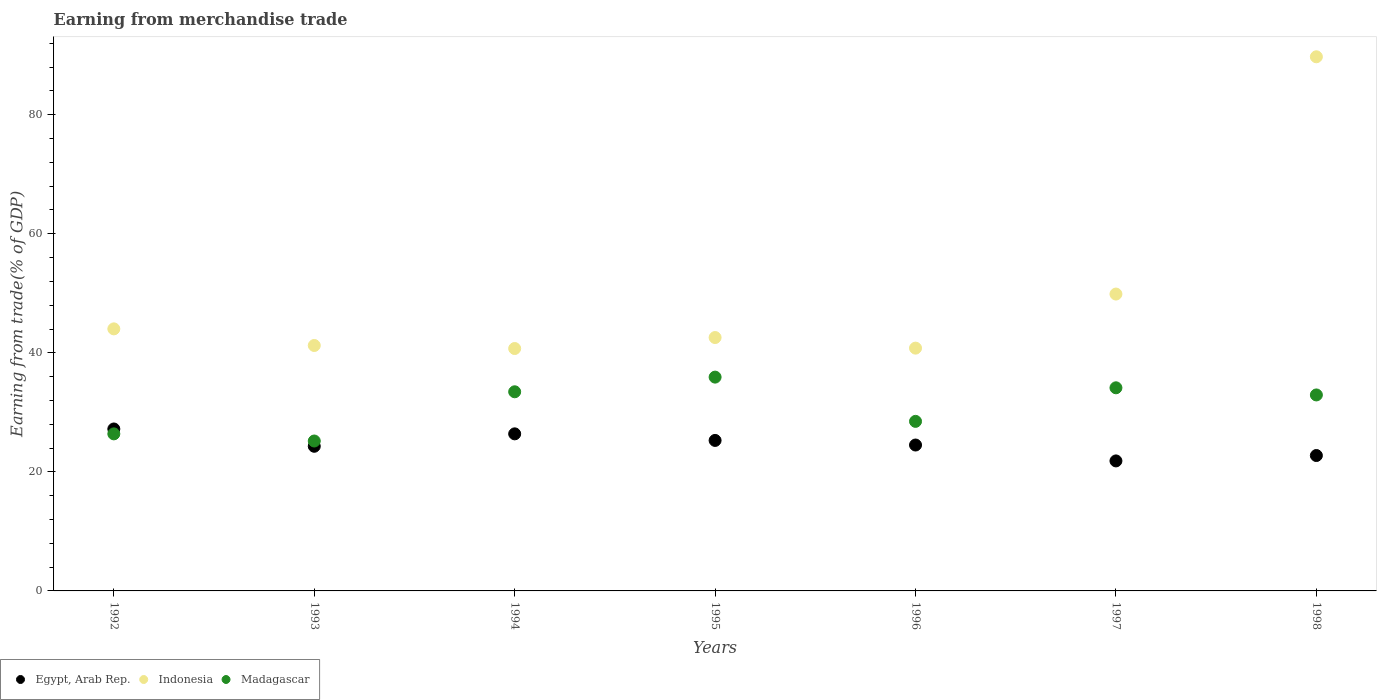What is the earnings from trade in Indonesia in 1993?
Your answer should be very brief. 41.23. Across all years, what is the maximum earnings from trade in Madagascar?
Provide a short and direct response. 35.92. Across all years, what is the minimum earnings from trade in Indonesia?
Make the answer very short. 40.72. In which year was the earnings from trade in Indonesia maximum?
Make the answer very short. 1998. What is the total earnings from trade in Madagascar in the graph?
Your answer should be very brief. 216.48. What is the difference between the earnings from trade in Madagascar in 1992 and that in 1993?
Your response must be concise. 1.2. What is the difference between the earnings from trade in Egypt, Arab Rep. in 1997 and the earnings from trade in Madagascar in 1996?
Provide a succinct answer. -6.64. What is the average earnings from trade in Egypt, Arab Rep. per year?
Your answer should be very brief. 24.61. In the year 1993, what is the difference between the earnings from trade in Indonesia and earnings from trade in Madagascar?
Your response must be concise. 16.05. In how many years, is the earnings from trade in Indonesia greater than 84 %?
Your answer should be very brief. 1. What is the ratio of the earnings from trade in Indonesia in 1993 to that in 1997?
Provide a succinct answer. 0.83. Is the earnings from trade in Madagascar in 1993 less than that in 1997?
Ensure brevity in your answer.  Yes. What is the difference between the highest and the second highest earnings from trade in Egypt, Arab Rep.?
Provide a succinct answer. 0.82. What is the difference between the highest and the lowest earnings from trade in Madagascar?
Provide a succinct answer. 10.73. Does the earnings from trade in Egypt, Arab Rep. monotonically increase over the years?
Give a very brief answer. No. Is the earnings from trade in Indonesia strictly greater than the earnings from trade in Madagascar over the years?
Provide a succinct answer. Yes. How many dotlines are there?
Provide a succinct answer. 3. Does the graph contain any zero values?
Offer a very short reply. No. What is the title of the graph?
Give a very brief answer. Earning from merchandise trade. Does "Bhutan" appear as one of the legend labels in the graph?
Provide a succinct answer. No. What is the label or title of the X-axis?
Keep it short and to the point. Years. What is the label or title of the Y-axis?
Offer a terse response. Earning from trade(% of GDP). What is the Earning from trade(% of GDP) in Egypt, Arab Rep. in 1992?
Provide a succinct answer. 27.21. What is the Earning from trade(% of GDP) of Indonesia in 1992?
Your answer should be compact. 44.03. What is the Earning from trade(% of GDP) of Madagascar in 1992?
Keep it short and to the point. 26.38. What is the Earning from trade(% of GDP) in Egypt, Arab Rep. in 1993?
Offer a terse response. 24.3. What is the Earning from trade(% of GDP) of Indonesia in 1993?
Provide a short and direct response. 41.23. What is the Earning from trade(% of GDP) in Madagascar in 1993?
Give a very brief answer. 25.19. What is the Earning from trade(% of GDP) of Egypt, Arab Rep. in 1994?
Provide a succinct answer. 26.39. What is the Earning from trade(% of GDP) of Indonesia in 1994?
Your answer should be compact. 40.72. What is the Earning from trade(% of GDP) in Madagascar in 1994?
Offer a very short reply. 33.46. What is the Earning from trade(% of GDP) in Egypt, Arab Rep. in 1995?
Offer a very short reply. 25.28. What is the Earning from trade(% of GDP) in Indonesia in 1995?
Offer a terse response. 42.57. What is the Earning from trade(% of GDP) of Madagascar in 1995?
Your answer should be very brief. 35.92. What is the Earning from trade(% of GDP) in Egypt, Arab Rep. in 1996?
Your answer should be very brief. 24.51. What is the Earning from trade(% of GDP) in Indonesia in 1996?
Keep it short and to the point. 40.79. What is the Earning from trade(% of GDP) in Madagascar in 1996?
Your answer should be very brief. 28.49. What is the Earning from trade(% of GDP) in Egypt, Arab Rep. in 1997?
Your answer should be very brief. 21.84. What is the Earning from trade(% of GDP) of Indonesia in 1997?
Make the answer very short. 49.87. What is the Earning from trade(% of GDP) of Madagascar in 1997?
Your answer should be very brief. 34.13. What is the Earning from trade(% of GDP) in Egypt, Arab Rep. in 1998?
Offer a terse response. 22.75. What is the Earning from trade(% of GDP) of Indonesia in 1998?
Make the answer very short. 89.74. What is the Earning from trade(% of GDP) in Madagascar in 1998?
Provide a succinct answer. 32.93. Across all years, what is the maximum Earning from trade(% of GDP) in Egypt, Arab Rep.?
Provide a short and direct response. 27.21. Across all years, what is the maximum Earning from trade(% of GDP) in Indonesia?
Your response must be concise. 89.74. Across all years, what is the maximum Earning from trade(% of GDP) of Madagascar?
Give a very brief answer. 35.92. Across all years, what is the minimum Earning from trade(% of GDP) in Egypt, Arab Rep.?
Give a very brief answer. 21.84. Across all years, what is the minimum Earning from trade(% of GDP) in Indonesia?
Give a very brief answer. 40.72. Across all years, what is the minimum Earning from trade(% of GDP) of Madagascar?
Give a very brief answer. 25.19. What is the total Earning from trade(% of GDP) in Egypt, Arab Rep. in the graph?
Keep it short and to the point. 172.28. What is the total Earning from trade(% of GDP) in Indonesia in the graph?
Provide a short and direct response. 348.95. What is the total Earning from trade(% of GDP) in Madagascar in the graph?
Make the answer very short. 216.48. What is the difference between the Earning from trade(% of GDP) in Egypt, Arab Rep. in 1992 and that in 1993?
Keep it short and to the point. 2.91. What is the difference between the Earning from trade(% of GDP) of Indonesia in 1992 and that in 1993?
Offer a very short reply. 2.79. What is the difference between the Earning from trade(% of GDP) in Madagascar in 1992 and that in 1993?
Provide a succinct answer. 1.2. What is the difference between the Earning from trade(% of GDP) in Egypt, Arab Rep. in 1992 and that in 1994?
Your response must be concise. 0.82. What is the difference between the Earning from trade(% of GDP) in Indonesia in 1992 and that in 1994?
Your answer should be very brief. 3.3. What is the difference between the Earning from trade(% of GDP) in Madagascar in 1992 and that in 1994?
Your response must be concise. -7.07. What is the difference between the Earning from trade(% of GDP) of Egypt, Arab Rep. in 1992 and that in 1995?
Your response must be concise. 1.92. What is the difference between the Earning from trade(% of GDP) in Indonesia in 1992 and that in 1995?
Provide a succinct answer. 1.46. What is the difference between the Earning from trade(% of GDP) in Madagascar in 1992 and that in 1995?
Offer a terse response. -9.53. What is the difference between the Earning from trade(% of GDP) in Egypt, Arab Rep. in 1992 and that in 1996?
Make the answer very short. 2.7. What is the difference between the Earning from trade(% of GDP) of Indonesia in 1992 and that in 1996?
Give a very brief answer. 3.24. What is the difference between the Earning from trade(% of GDP) of Madagascar in 1992 and that in 1996?
Your answer should be compact. -2.1. What is the difference between the Earning from trade(% of GDP) in Egypt, Arab Rep. in 1992 and that in 1997?
Give a very brief answer. 5.37. What is the difference between the Earning from trade(% of GDP) of Indonesia in 1992 and that in 1997?
Provide a short and direct response. -5.85. What is the difference between the Earning from trade(% of GDP) in Madagascar in 1992 and that in 1997?
Ensure brevity in your answer.  -7.74. What is the difference between the Earning from trade(% of GDP) in Egypt, Arab Rep. in 1992 and that in 1998?
Provide a short and direct response. 4.46. What is the difference between the Earning from trade(% of GDP) in Indonesia in 1992 and that in 1998?
Offer a very short reply. -45.71. What is the difference between the Earning from trade(% of GDP) in Madagascar in 1992 and that in 1998?
Ensure brevity in your answer.  -6.54. What is the difference between the Earning from trade(% of GDP) in Egypt, Arab Rep. in 1993 and that in 1994?
Your answer should be compact. -2.09. What is the difference between the Earning from trade(% of GDP) of Indonesia in 1993 and that in 1994?
Your answer should be compact. 0.51. What is the difference between the Earning from trade(% of GDP) in Madagascar in 1993 and that in 1994?
Offer a very short reply. -8.27. What is the difference between the Earning from trade(% of GDP) of Egypt, Arab Rep. in 1993 and that in 1995?
Provide a short and direct response. -0.98. What is the difference between the Earning from trade(% of GDP) of Indonesia in 1993 and that in 1995?
Your answer should be compact. -1.34. What is the difference between the Earning from trade(% of GDP) in Madagascar in 1993 and that in 1995?
Your response must be concise. -10.73. What is the difference between the Earning from trade(% of GDP) in Egypt, Arab Rep. in 1993 and that in 1996?
Offer a very short reply. -0.21. What is the difference between the Earning from trade(% of GDP) of Indonesia in 1993 and that in 1996?
Ensure brevity in your answer.  0.44. What is the difference between the Earning from trade(% of GDP) of Madagascar in 1993 and that in 1996?
Give a very brief answer. -3.3. What is the difference between the Earning from trade(% of GDP) of Egypt, Arab Rep. in 1993 and that in 1997?
Make the answer very short. 2.46. What is the difference between the Earning from trade(% of GDP) in Indonesia in 1993 and that in 1997?
Make the answer very short. -8.64. What is the difference between the Earning from trade(% of GDP) in Madagascar in 1993 and that in 1997?
Your answer should be very brief. -8.94. What is the difference between the Earning from trade(% of GDP) of Egypt, Arab Rep. in 1993 and that in 1998?
Your answer should be compact. 1.55. What is the difference between the Earning from trade(% of GDP) in Indonesia in 1993 and that in 1998?
Provide a succinct answer. -48.5. What is the difference between the Earning from trade(% of GDP) of Madagascar in 1993 and that in 1998?
Offer a very short reply. -7.74. What is the difference between the Earning from trade(% of GDP) in Egypt, Arab Rep. in 1994 and that in 1995?
Make the answer very short. 1.11. What is the difference between the Earning from trade(% of GDP) in Indonesia in 1994 and that in 1995?
Provide a short and direct response. -1.85. What is the difference between the Earning from trade(% of GDP) in Madagascar in 1994 and that in 1995?
Give a very brief answer. -2.46. What is the difference between the Earning from trade(% of GDP) in Egypt, Arab Rep. in 1994 and that in 1996?
Provide a short and direct response. 1.88. What is the difference between the Earning from trade(% of GDP) of Indonesia in 1994 and that in 1996?
Give a very brief answer. -0.07. What is the difference between the Earning from trade(% of GDP) in Madagascar in 1994 and that in 1996?
Your response must be concise. 4.97. What is the difference between the Earning from trade(% of GDP) of Egypt, Arab Rep. in 1994 and that in 1997?
Provide a succinct answer. 4.55. What is the difference between the Earning from trade(% of GDP) in Indonesia in 1994 and that in 1997?
Your answer should be very brief. -9.15. What is the difference between the Earning from trade(% of GDP) of Madagascar in 1994 and that in 1997?
Offer a terse response. -0.67. What is the difference between the Earning from trade(% of GDP) of Egypt, Arab Rep. in 1994 and that in 1998?
Keep it short and to the point. 3.64. What is the difference between the Earning from trade(% of GDP) in Indonesia in 1994 and that in 1998?
Offer a terse response. -49.01. What is the difference between the Earning from trade(% of GDP) of Madagascar in 1994 and that in 1998?
Provide a short and direct response. 0.53. What is the difference between the Earning from trade(% of GDP) in Egypt, Arab Rep. in 1995 and that in 1996?
Provide a short and direct response. 0.77. What is the difference between the Earning from trade(% of GDP) in Indonesia in 1995 and that in 1996?
Give a very brief answer. 1.78. What is the difference between the Earning from trade(% of GDP) of Madagascar in 1995 and that in 1996?
Your answer should be compact. 7.43. What is the difference between the Earning from trade(% of GDP) of Egypt, Arab Rep. in 1995 and that in 1997?
Keep it short and to the point. 3.44. What is the difference between the Earning from trade(% of GDP) of Indonesia in 1995 and that in 1997?
Your response must be concise. -7.3. What is the difference between the Earning from trade(% of GDP) of Madagascar in 1995 and that in 1997?
Your response must be concise. 1.79. What is the difference between the Earning from trade(% of GDP) in Egypt, Arab Rep. in 1995 and that in 1998?
Your answer should be very brief. 2.54. What is the difference between the Earning from trade(% of GDP) of Indonesia in 1995 and that in 1998?
Your answer should be very brief. -47.17. What is the difference between the Earning from trade(% of GDP) of Madagascar in 1995 and that in 1998?
Your response must be concise. 2.99. What is the difference between the Earning from trade(% of GDP) of Egypt, Arab Rep. in 1996 and that in 1997?
Keep it short and to the point. 2.67. What is the difference between the Earning from trade(% of GDP) of Indonesia in 1996 and that in 1997?
Your answer should be very brief. -9.08. What is the difference between the Earning from trade(% of GDP) of Madagascar in 1996 and that in 1997?
Give a very brief answer. -5.64. What is the difference between the Earning from trade(% of GDP) of Egypt, Arab Rep. in 1996 and that in 1998?
Your response must be concise. 1.76. What is the difference between the Earning from trade(% of GDP) of Indonesia in 1996 and that in 1998?
Offer a very short reply. -48.95. What is the difference between the Earning from trade(% of GDP) of Madagascar in 1996 and that in 1998?
Your answer should be very brief. -4.44. What is the difference between the Earning from trade(% of GDP) in Egypt, Arab Rep. in 1997 and that in 1998?
Offer a terse response. -0.91. What is the difference between the Earning from trade(% of GDP) of Indonesia in 1997 and that in 1998?
Offer a terse response. -39.86. What is the difference between the Earning from trade(% of GDP) of Madagascar in 1997 and that in 1998?
Keep it short and to the point. 1.2. What is the difference between the Earning from trade(% of GDP) in Egypt, Arab Rep. in 1992 and the Earning from trade(% of GDP) in Indonesia in 1993?
Your answer should be very brief. -14.03. What is the difference between the Earning from trade(% of GDP) in Egypt, Arab Rep. in 1992 and the Earning from trade(% of GDP) in Madagascar in 1993?
Your response must be concise. 2.02. What is the difference between the Earning from trade(% of GDP) of Indonesia in 1992 and the Earning from trade(% of GDP) of Madagascar in 1993?
Make the answer very short. 18.84. What is the difference between the Earning from trade(% of GDP) in Egypt, Arab Rep. in 1992 and the Earning from trade(% of GDP) in Indonesia in 1994?
Keep it short and to the point. -13.52. What is the difference between the Earning from trade(% of GDP) of Egypt, Arab Rep. in 1992 and the Earning from trade(% of GDP) of Madagascar in 1994?
Make the answer very short. -6.25. What is the difference between the Earning from trade(% of GDP) of Indonesia in 1992 and the Earning from trade(% of GDP) of Madagascar in 1994?
Keep it short and to the point. 10.57. What is the difference between the Earning from trade(% of GDP) in Egypt, Arab Rep. in 1992 and the Earning from trade(% of GDP) in Indonesia in 1995?
Your response must be concise. -15.36. What is the difference between the Earning from trade(% of GDP) of Egypt, Arab Rep. in 1992 and the Earning from trade(% of GDP) of Madagascar in 1995?
Provide a short and direct response. -8.71. What is the difference between the Earning from trade(% of GDP) of Indonesia in 1992 and the Earning from trade(% of GDP) of Madagascar in 1995?
Make the answer very short. 8.11. What is the difference between the Earning from trade(% of GDP) of Egypt, Arab Rep. in 1992 and the Earning from trade(% of GDP) of Indonesia in 1996?
Make the answer very short. -13.58. What is the difference between the Earning from trade(% of GDP) in Egypt, Arab Rep. in 1992 and the Earning from trade(% of GDP) in Madagascar in 1996?
Provide a short and direct response. -1.28. What is the difference between the Earning from trade(% of GDP) of Indonesia in 1992 and the Earning from trade(% of GDP) of Madagascar in 1996?
Ensure brevity in your answer.  15.54. What is the difference between the Earning from trade(% of GDP) of Egypt, Arab Rep. in 1992 and the Earning from trade(% of GDP) of Indonesia in 1997?
Your answer should be very brief. -22.67. What is the difference between the Earning from trade(% of GDP) of Egypt, Arab Rep. in 1992 and the Earning from trade(% of GDP) of Madagascar in 1997?
Offer a terse response. -6.92. What is the difference between the Earning from trade(% of GDP) of Indonesia in 1992 and the Earning from trade(% of GDP) of Madagascar in 1997?
Ensure brevity in your answer.  9.9. What is the difference between the Earning from trade(% of GDP) in Egypt, Arab Rep. in 1992 and the Earning from trade(% of GDP) in Indonesia in 1998?
Give a very brief answer. -62.53. What is the difference between the Earning from trade(% of GDP) of Egypt, Arab Rep. in 1992 and the Earning from trade(% of GDP) of Madagascar in 1998?
Keep it short and to the point. -5.72. What is the difference between the Earning from trade(% of GDP) of Indonesia in 1992 and the Earning from trade(% of GDP) of Madagascar in 1998?
Your response must be concise. 11.1. What is the difference between the Earning from trade(% of GDP) of Egypt, Arab Rep. in 1993 and the Earning from trade(% of GDP) of Indonesia in 1994?
Your response must be concise. -16.42. What is the difference between the Earning from trade(% of GDP) of Egypt, Arab Rep. in 1993 and the Earning from trade(% of GDP) of Madagascar in 1994?
Offer a terse response. -9.16. What is the difference between the Earning from trade(% of GDP) in Indonesia in 1993 and the Earning from trade(% of GDP) in Madagascar in 1994?
Offer a very short reply. 7.78. What is the difference between the Earning from trade(% of GDP) of Egypt, Arab Rep. in 1993 and the Earning from trade(% of GDP) of Indonesia in 1995?
Your response must be concise. -18.27. What is the difference between the Earning from trade(% of GDP) of Egypt, Arab Rep. in 1993 and the Earning from trade(% of GDP) of Madagascar in 1995?
Provide a short and direct response. -11.62. What is the difference between the Earning from trade(% of GDP) in Indonesia in 1993 and the Earning from trade(% of GDP) in Madagascar in 1995?
Provide a short and direct response. 5.31. What is the difference between the Earning from trade(% of GDP) of Egypt, Arab Rep. in 1993 and the Earning from trade(% of GDP) of Indonesia in 1996?
Ensure brevity in your answer.  -16.49. What is the difference between the Earning from trade(% of GDP) of Egypt, Arab Rep. in 1993 and the Earning from trade(% of GDP) of Madagascar in 1996?
Your response must be concise. -4.18. What is the difference between the Earning from trade(% of GDP) of Indonesia in 1993 and the Earning from trade(% of GDP) of Madagascar in 1996?
Offer a terse response. 12.75. What is the difference between the Earning from trade(% of GDP) of Egypt, Arab Rep. in 1993 and the Earning from trade(% of GDP) of Indonesia in 1997?
Your answer should be very brief. -25.57. What is the difference between the Earning from trade(% of GDP) in Egypt, Arab Rep. in 1993 and the Earning from trade(% of GDP) in Madagascar in 1997?
Offer a very short reply. -9.82. What is the difference between the Earning from trade(% of GDP) of Indonesia in 1993 and the Earning from trade(% of GDP) of Madagascar in 1997?
Offer a very short reply. 7.11. What is the difference between the Earning from trade(% of GDP) in Egypt, Arab Rep. in 1993 and the Earning from trade(% of GDP) in Indonesia in 1998?
Offer a very short reply. -65.44. What is the difference between the Earning from trade(% of GDP) in Egypt, Arab Rep. in 1993 and the Earning from trade(% of GDP) in Madagascar in 1998?
Give a very brief answer. -8.62. What is the difference between the Earning from trade(% of GDP) of Indonesia in 1993 and the Earning from trade(% of GDP) of Madagascar in 1998?
Ensure brevity in your answer.  8.31. What is the difference between the Earning from trade(% of GDP) of Egypt, Arab Rep. in 1994 and the Earning from trade(% of GDP) of Indonesia in 1995?
Your answer should be compact. -16.18. What is the difference between the Earning from trade(% of GDP) in Egypt, Arab Rep. in 1994 and the Earning from trade(% of GDP) in Madagascar in 1995?
Provide a short and direct response. -9.53. What is the difference between the Earning from trade(% of GDP) in Indonesia in 1994 and the Earning from trade(% of GDP) in Madagascar in 1995?
Keep it short and to the point. 4.81. What is the difference between the Earning from trade(% of GDP) in Egypt, Arab Rep. in 1994 and the Earning from trade(% of GDP) in Indonesia in 1996?
Offer a terse response. -14.4. What is the difference between the Earning from trade(% of GDP) in Egypt, Arab Rep. in 1994 and the Earning from trade(% of GDP) in Madagascar in 1996?
Offer a terse response. -2.1. What is the difference between the Earning from trade(% of GDP) of Indonesia in 1994 and the Earning from trade(% of GDP) of Madagascar in 1996?
Provide a succinct answer. 12.24. What is the difference between the Earning from trade(% of GDP) in Egypt, Arab Rep. in 1994 and the Earning from trade(% of GDP) in Indonesia in 1997?
Your answer should be compact. -23.49. What is the difference between the Earning from trade(% of GDP) in Egypt, Arab Rep. in 1994 and the Earning from trade(% of GDP) in Madagascar in 1997?
Provide a short and direct response. -7.74. What is the difference between the Earning from trade(% of GDP) of Indonesia in 1994 and the Earning from trade(% of GDP) of Madagascar in 1997?
Your answer should be very brief. 6.6. What is the difference between the Earning from trade(% of GDP) in Egypt, Arab Rep. in 1994 and the Earning from trade(% of GDP) in Indonesia in 1998?
Your answer should be very brief. -63.35. What is the difference between the Earning from trade(% of GDP) in Egypt, Arab Rep. in 1994 and the Earning from trade(% of GDP) in Madagascar in 1998?
Offer a terse response. -6.54. What is the difference between the Earning from trade(% of GDP) in Indonesia in 1994 and the Earning from trade(% of GDP) in Madagascar in 1998?
Offer a very short reply. 7.8. What is the difference between the Earning from trade(% of GDP) in Egypt, Arab Rep. in 1995 and the Earning from trade(% of GDP) in Indonesia in 1996?
Your answer should be very brief. -15.51. What is the difference between the Earning from trade(% of GDP) in Egypt, Arab Rep. in 1995 and the Earning from trade(% of GDP) in Madagascar in 1996?
Provide a succinct answer. -3.2. What is the difference between the Earning from trade(% of GDP) of Indonesia in 1995 and the Earning from trade(% of GDP) of Madagascar in 1996?
Keep it short and to the point. 14.08. What is the difference between the Earning from trade(% of GDP) in Egypt, Arab Rep. in 1995 and the Earning from trade(% of GDP) in Indonesia in 1997?
Your answer should be very brief. -24.59. What is the difference between the Earning from trade(% of GDP) in Egypt, Arab Rep. in 1995 and the Earning from trade(% of GDP) in Madagascar in 1997?
Provide a short and direct response. -8.84. What is the difference between the Earning from trade(% of GDP) in Indonesia in 1995 and the Earning from trade(% of GDP) in Madagascar in 1997?
Keep it short and to the point. 8.44. What is the difference between the Earning from trade(% of GDP) of Egypt, Arab Rep. in 1995 and the Earning from trade(% of GDP) of Indonesia in 1998?
Provide a succinct answer. -64.45. What is the difference between the Earning from trade(% of GDP) of Egypt, Arab Rep. in 1995 and the Earning from trade(% of GDP) of Madagascar in 1998?
Keep it short and to the point. -7.64. What is the difference between the Earning from trade(% of GDP) of Indonesia in 1995 and the Earning from trade(% of GDP) of Madagascar in 1998?
Make the answer very short. 9.64. What is the difference between the Earning from trade(% of GDP) of Egypt, Arab Rep. in 1996 and the Earning from trade(% of GDP) of Indonesia in 1997?
Provide a succinct answer. -25.36. What is the difference between the Earning from trade(% of GDP) in Egypt, Arab Rep. in 1996 and the Earning from trade(% of GDP) in Madagascar in 1997?
Provide a succinct answer. -9.61. What is the difference between the Earning from trade(% of GDP) in Indonesia in 1996 and the Earning from trade(% of GDP) in Madagascar in 1997?
Make the answer very short. 6.66. What is the difference between the Earning from trade(% of GDP) in Egypt, Arab Rep. in 1996 and the Earning from trade(% of GDP) in Indonesia in 1998?
Keep it short and to the point. -65.23. What is the difference between the Earning from trade(% of GDP) of Egypt, Arab Rep. in 1996 and the Earning from trade(% of GDP) of Madagascar in 1998?
Make the answer very short. -8.41. What is the difference between the Earning from trade(% of GDP) in Indonesia in 1996 and the Earning from trade(% of GDP) in Madagascar in 1998?
Keep it short and to the point. 7.86. What is the difference between the Earning from trade(% of GDP) of Egypt, Arab Rep. in 1997 and the Earning from trade(% of GDP) of Indonesia in 1998?
Offer a terse response. -67.9. What is the difference between the Earning from trade(% of GDP) of Egypt, Arab Rep. in 1997 and the Earning from trade(% of GDP) of Madagascar in 1998?
Your answer should be compact. -11.08. What is the difference between the Earning from trade(% of GDP) of Indonesia in 1997 and the Earning from trade(% of GDP) of Madagascar in 1998?
Give a very brief answer. 16.95. What is the average Earning from trade(% of GDP) in Egypt, Arab Rep. per year?
Offer a terse response. 24.61. What is the average Earning from trade(% of GDP) in Indonesia per year?
Provide a short and direct response. 49.85. What is the average Earning from trade(% of GDP) of Madagascar per year?
Ensure brevity in your answer.  30.93. In the year 1992, what is the difference between the Earning from trade(% of GDP) of Egypt, Arab Rep. and Earning from trade(% of GDP) of Indonesia?
Give a very brief answer. -16.82. In the year 1992, what is the difference between the Earning from trade(% of GDP) of Egypt, Arab Rep. and Earning from trade(% of GDP) of Madagascar?
Your response must be concise. 0.82. In the year 1992, what is the difference between the Earning from trade(% of GDP) of Indonesia and Earning from trade(% of GDP) of Madagascar?
Provide a short and direct response. 17.64. In the year 1993, what is the difference between the Earning from trade(% of GDP) in Egypt, Arab Rep. and Earning from trade(% of GDP) in Indonesia?
Your response must be concise. -16.93. In the year 1993, what is the difference between the Earning from trade(% of GDP) of Egypt, Arab Rep. and Earning from trade(% of GDP) of Madagascar?
Offer a very short reply. -0.89. In the year 1993, what is the difference between the Earning from trade(% of GDP) in Indonesia and Earning from trade(% of GDP) in Madagascar?
Provide a short and direct response. 16.05. In the year 1994, what is the difference between the Earning from trade(% of GDP) in Egypt, Arab Rep. and Earning from trade(% of GDP) in Indonesia?
Provide a succinct answer. -14.34. In the year 1994, what is the difference between the Earning from trade(% of GDP) of Egypt, Arab Rep. and Earning from trade(% of GDP) of Madagascar?
Ensure brevity in your answer.  -7.07. In the year 1994, what is the difference between the Earning from trade(% of GDP) of Indonesia and Earning from trade(% of GDP) of Madagascar?
Your response must be concise. 7.27. In the year 1995, what is the difference between the Earning from trade(% of GDP) of Egypt, Arab Rep. and Earning from trade(% of GDP) of Indonesia?
Provide a short and direct response. -17.29. In the year 1995, what is the difference between the Earning from trade(% of GDP) of Egypt, Arab Rep. and Earning from trade(% of GDP) of Madagascar?
Offer a very short reply. -10.64. In the year 1995, what is the difference between the Earning from trade(% of GDP) of Indonesia and Earning from trade(% of GDP) of Madagascar?
Keep it short and to the point. 6.65. In the year 1996, what is the difference between the Earning from trade(% of GDP) in Egypt, Arab Rep. and Earning from trade(% of GDP) in Indonesia?
Your answer should be very brief. -16.28. In the year 1996, what is the difference between the Earning from trade(% of GDP) of Egypt, Arab Rep. and Earning from trade(% of GDP) of Madagascar?
Provide a succinct answer. -3.97. In the year 1996, what is the difference between the Earning from trade(% of GDP) in Indonesia and Earning from trade(% of GDP) in Madagascar?
Give a very brief answer. 12.3. In the year 1997, what is the difference between the Earning from trade(% of GDP) in Egypt, Arab Rep. and Earning from trade(% of GDP) in Indonesia?
Your answer should be very brief. -28.03. In the year 1997, what is the difference between the Earning from trade(% of GDP) in Egypt, Arab Rep. and Earning from trade(% of GDP) in Madagascar?
Your response must be concise. -12.28. In the year 1997, what is the difference between the Earning from trade(% of GDP) in Indonesia and Earning from trade(% of GDP) in Madagascar?
Provide a short and direct response. 15.75. In the year 1998, what is the difference between the Earning from trade(% of GDP) in Egypt, Arab Rep. and Earning from trade(% of GDP) in Indonesia?
Ensure brevity in your answer.  -66.99. In the year 1998, what is the difference between the Earning from trade(% of GDP) of Egypt, Arab Rep. and Earning from trade(% of GDP) of Madagascar?
Provide a succinct answer. -10.18. In the year 1998, what is the difference between the Earning from trade(% of GDP) in Indonesia and Earning from trade(% of GDP) in Madagascar?
Your response must be concise. 56.81. What is the ratio of the Earning from trade(% of GDP) in Egypt, Arab Rep. in 1992 to that in 1993?
Your answer should be compact. 1.12. What is the ratio of the Earning from trade(% of GDP) in Indonesia in 1992 to that in 1993?
Ensure brevity in your answer.  1.07. What is the ratio of the Earning from trade(% of GDP) in Madagascar in 1992 to that in 1993?
Make the answer very short. 1.05. What is the ratio of the Earning from trade(% of GDP) of Egypt, Arab Rep. in 1992 to that in 1994?
Give a very brief answer. 1.03. What is the ratio of the Earning from trade(% of GDP) in Indonesia in 1992 to that in 1994?
Provide a succinct answer. 1.08. What is the ratio of the Earning from trade(% of GDP) of Madagascar in 1992 to that in 1994?
Your response must be concise. 0.79. What is the ratio of the Earning from trade(% of GDP) of Egypt, Arab Rep. in 1992 to that in 1995?
Give a very brief answer. 1.08. What is the ratio of the Earning from trade(% of GDP) of Indonesia in 1992 to that in 1995?
Offer a terse response. 1.03. What is the ratio of the Earning from trade(% of GDP) of Madagascar in 1992 to that in 1995?
Keep it short and to the point. 0.73. What is the ratio of the Earning from trade(% of GDP) of Egypt, Arab Rep. in 1992 to that in 1996?
Make the answer very short. 1.11. What is the ratio of the Earning from trade(% of GDP) in Indonesia in 1992 to that in 1996?
Provide a short and direct response. 1.08. What is the ratio of the Earning from trade(% of GDP) in Madagascar in 1992 to that in 1996?
Keep it short and to the point. 0.93. What is the ratio of the Earning from trade(% of GDP) of Egypt, Arab Rep. in 1992 to that in 1997?
Provide a succinct answer. 1.25. What is the ratio of the Earning from trade(% of GDP) in Indonesia in 1992 to that in 1997?
Your answer should be very brief. 0.88. What is the ratio of the Earning from trade(% of GDP) of Madagascar in 1992 to that in 1997?
Keep it short and to the point. 0.77. What is the ratio of the Earning from trade(% of GDP) in Egypt, Arab Rep. in 1992 to that in 1998?
Your answer should be very brief. 1.2. What is the ratio of the Earning from trade(% of GDP) of Indonesia in 1992 to that in 1998?
Provide a short and direct response. 0.49. What is the ratio of the Earning from trade(% of GDP) of Madagascar in 1992 to that in 1998?
Provide a short and direct response. 0.8. What is the ratio of the Earning from trade(% of GDP) of Egypt, Arab Rep. in 1993 to that in 1994?
Provide a succinct answer. 0.92. What is the ratio of the Earning from trade(% of GDP) of Indonesia in 1993 to that in 1994?
Your response must be concise. 1.01. What is the ratio of the Earning from trade(% of GDP) of Madagascar in 1993 to that in 1994?
Offer a terse response. 0.75. What is the ratio of the Earning from trade(% of GDP) in Egypt, Arab Rep. in 1993 to that in 1995?
Offer a terse response. 0.96. What is the ratio of the Earning from trade(% of GDP) in Indonesia in 1993 to that in 1995?
Keep it short and to the point. 0.97. What is the ratio of the Earning from trade(% of GDP) of Madagascar in 1993 to that in 1995?
Keep it short and to the point. 0.7. What is the ratio of the Earning from trade(% of GDP) in Indonesia in 1993 to that in 1996?
Offer a very short reply. 1.01. What is the ratio of the Earning from trade(% of GDP) of Madagascar in 1993 to that in 1996?
Your answer should be very brief. 0.88. What is the ratio of the Earning from trade(% of GDP) in Egypt, Arab Rep. in 1993 to that in 1997?
Keep it short and to the point. 1.11. What is the ratio of the Earning from trade(% of GDP) in Indonesia in 1993 to that in 1997?
Provide a succinct answer. 0.83. What is the ratio of the Earning from trade(% of GDP) in Madagascar in 1993 to that in 1997?
Ensure brevity in your answer.  0.74. What is the ratio of the Earning from trade(% of GDP) of Egypt, Arab Rep. in 1993 to that in 1998?
Your answer should be compact. 1.07. What is the ratio of the Earning from trade(% of GDP) of Indonesia in 1993 to that in 1998?
Offer a terse response. 0.46. What is the ratio of the Earning from trade(% of GDP) of Madagascar in 1993 to that in 1998?
Give a very brief answer. 0.76. What is the ratio of the Earning from trade(% of GDP) in Egypt, Arab Rep. in 1994 to that in 1995?
Provide a short and direct response. 1.04. What is the ratio of the Earning from trade(% of GDP) of Indonesia in 1994 to that in 1995?
Give a very brief answer. 0.96. What is the ratio of the Earning from trade(% of GDP) in Madagascar in 1994 to that in 1995?
Offer a very short reply. 0.93. What is the ratio of the Earning from trade(% of GDP) of Egypt, Arab Rep. in 1994 to that in 1996?
Your answer should be very brief. 1.08. What is the ratio of the Earning from trade(% of GDP) in Indonesia in 1994 to that in 1996?
Ensure brevity in your answer.  1. What is the ratio of the Earning from trade(% of GDP) in Madagascar in 1994 to that in 1996?
Your response must be concise. 1.17. What is the ratio of the Earning from trade(% of GDP) in Egypt, Arab Rep. in 1994 to that in 1997?
Give a very brief answer. 1.21. What is the ratio of the Earning from trade(% of GDP) of Indonesia in 1994 to that in 1997?
Your answer should be compact. 0.82. What is the ratio of the Earning from trade(% of GDP) of Madagascar in 1994 to that in 1997?
Keep it short and to the point. 0.98. What is the ratio of the Earning from trade(% of GDP) of Egypt, Arab Rep. in 1994 to that in 1998?
Make the answer very short. 1.16. What is the ratio of the Earning from trade(% of GDP) of Indonesia in 1994 to that in 1998?
Keep it short and to the point. 0.45. What is the ratio of the Earning from trade(% of GDP) in Madagascar in 1994 to that in 1998?
Offer a very short reply. 1.02. What is the ratio of the Earning from trade(% of GDP) of Egypt, Arab Rep. in 1995 to that in 1996?
Your response must be concise. 1.03. What is the ratio of the Earning from trade(% of GDP) of Indonesia in 1995 to that in 1996?
Make the answer very short. 1.04. What is the ratio of the Earning from trade(% of GDP) of Madagascar in 1995 to that in 1996?
Provide a succinct answer. 1.26. What is the ratio of the Earning from trade(% of GDP) in Egypt, Arab Rep. in 1995 to that in 1997?
Your answer should be compact. 1.16. What is the ratio of the Earning from trade(% of GDP) in Indonesia in 1995 to that in 1997?
Provide a succinct answer. 0.85. What is the ratio of the Earning from trade(% of GDP) in Madagascar in 1995 to that in 1997?
Provide a succinct answer. 1.05. What is the ratio of the Earning from trade(% of GDP) of Egypt, Arab Rep. in 1995 to that in 1998?
Ensure brevity in your answer.  1.11. What is the ratio of the Earning from trade(% of GDP) of Indonesia in 1995 to that in 1998?
Give a very brief answer. 0.47. What is the ratio of the Earning from trade(% of GDP) of Madagascar in 1995 to that in 1998?
Make the answer very short. 1.09. What is the ratio of the Earning from trade(% of GDP) in Egypt, Arab Rep. in 1996 to that in 1997?
Your response must be concise. 1.12. What is the ratio of the Earning from trade(% of GDP) of Indonesia in 1996 to that in 1997?
Your answer should be compact. 0.82. What is the ratio of the Earning from trade(% of GDP) in Madagascar in 1996 to that in 1997?
Offer a very short reply. 0.83. What is the ratio of the Earning from trade(% of GDP) in Egypt, Arab Rep. in 1996 to that in 1998?
Ensure brevity in your answer.  1.08. What is the ratio of the Earning from trade(% of GDP) of Indonesia in 1996 to that in 1998?
Provide a short and direct response. 0.45. What is the ratio of the Earning from trade(% of GDP) of Madagascar in 1996 to that in 1998?
Provide a succinct answer. 0.87. What is the ratio of the Earning from trade(% of GDP) in Egypt, Arab Rep. in 1997 to that in 1998?
Make the answer very short. 0.96. What is the ratio of the Earning from trade(% of GDP) in Indonesia in 1997 to that in 1998?
Provide a short and direct response. 0.56. What is the ratio of the Earning from trade(% of GDP) of Madagascar in 1997 to that in 1998?
Make the answer very short. 1.04. What is the difference between the highest and the second highest Earning from trade(% of GDP) in Egypt, Arab Rep.?
Keep it short and to the point. 0.82. What is the difference between the highest and the second highest Earning from trade(% of GDP) of Indonesia?
Keep it short and to the point. 39.86. What is the difference between the highest and the second highest Earning from trade(% of GDP) in Madagascar?
Give a very brief answer. 1.79. What is the difference between the highest and the lowest Earning from trade(% of GDP) in Egypt, Arab Rep.?
Your response must be concise. 5.37. What is the difference between the highest and the lowest Earning from trade(% of GDP) in Indonesia?
Your answer should be very brief. 49.01. What is the difference between the highest and the lowest Earning from trade(% of GDP) in Madagascar?
Make the answer very short. 10.73. 